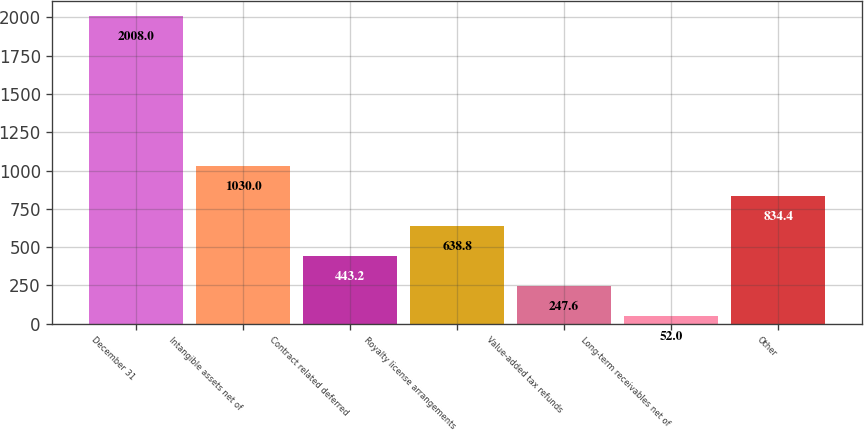Convert chart. <chart><loc_0><loc_0><loc_500><loc_500><bar_chart><fcel>December 31<fcel>Intangible assets net of<fcel>Contract related deferred<fcel>Royalty license arrangements<fcel>Value-added tax refunds<fcel>Long-term receivables net of<fcel>Other<nl><fcel>2008<fcel>1030<fcel>443.2<fcel>638.8<fcel>247.6<fcel>52<fcel>834.4<nl></chart> 